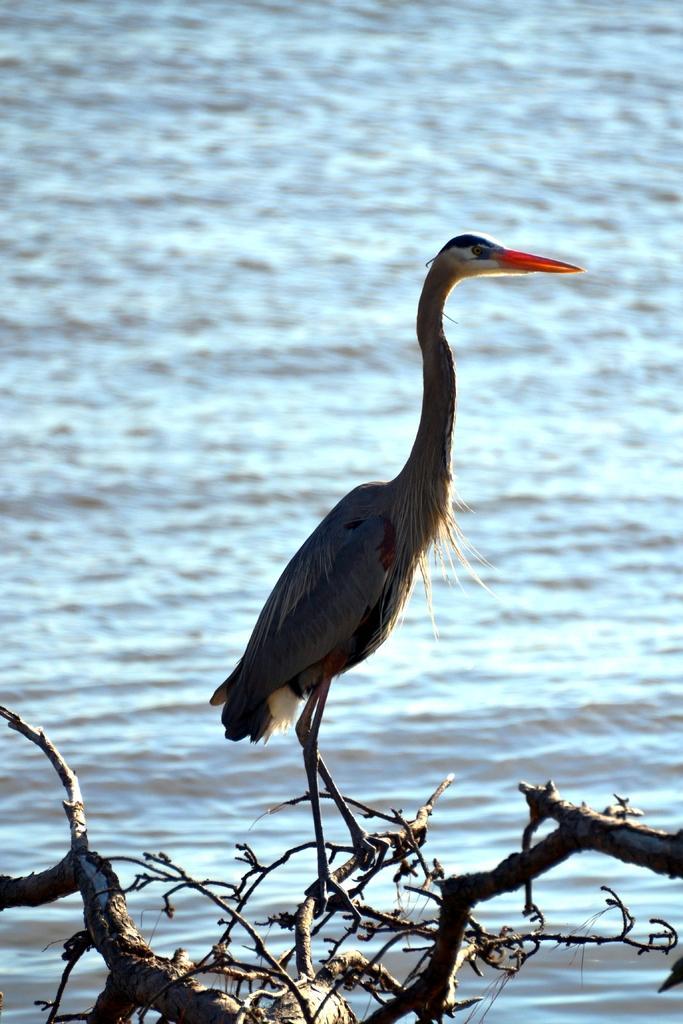Please provide a concise description of this image. Here in this picture we can see a water bird present on a branch of a tree and we can see water present all over there. 